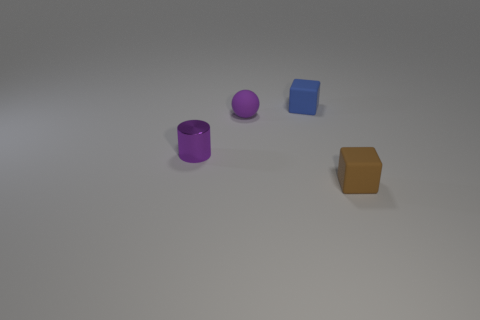Imagine these objects are part of a game. What could be the objective involving these items? In a creative gaming scenario, these objects could serve as pieces in a puzzle-solving game. The goal might be to arrange them in a specific pattern based on their shapes and colors or stack them according to certain rules to complete levels or challenges. 